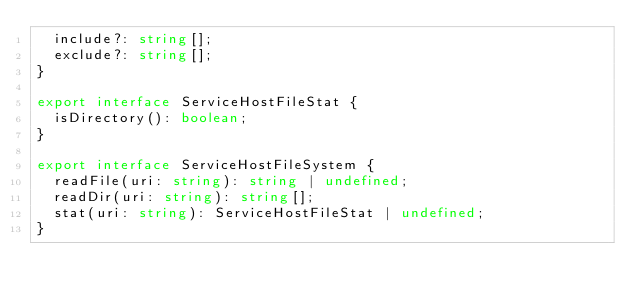<code> <loc_0><loc_0><loc_500><loc_500><_TypeScript_>  include?: string[];
  exclude?: string[];
}

export interface ServiceHostFileStat {
  isDirectory(): boolean;
}

export interface ServiceHostFileSystem {
  readFile(uri: string): string | undefined;
  readDir(uri: string): string[];
  stat(uri: string): ServiceHostFileStat | undefined;
}
</code> 